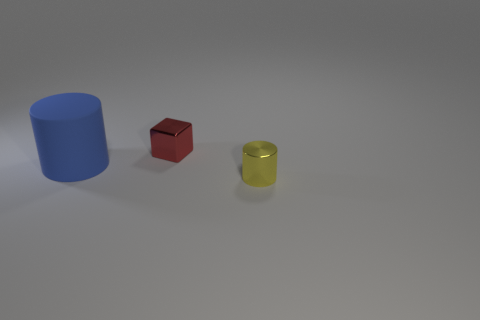How many small metallic things are on the right side of the red metallic block?
Provide a succinct answer. 1. Are there the same number of red cubes that are in front of the yellow metal cylinder and red cubes that are to the right of the large rubber cylinder?
Ensure brevity in your answer.  No. There is a rubber object that is the same shape as the tiny yellow shiny object; what is its size?
Give a very brief answer. Large. The shiny thing in front of the red block has what shape?
Ensure brevity in your answer.  Cylinder. Is the material of the big cylinder left of the small red shiny cube the same as the object that is to the right of the small cube?
Your answer should be compact. No. What is the shape of the big blue rubber thing?
Offer a very short reply. Cylinder. Are there the same number of small yellow metallic cylinders on the right side of the yellow shiny cylinder and red cubes?
Your response must be concise. No. Are there any large objects that have the same material as the block?
Your response must be concise. No. There is a tiny thing that is behind the big object; is its shape the same as the thing that is in front of the big blue matte object?
Keep it short and to the point. No. Are any small metal things visible?
Offer a terse response. Yes. 